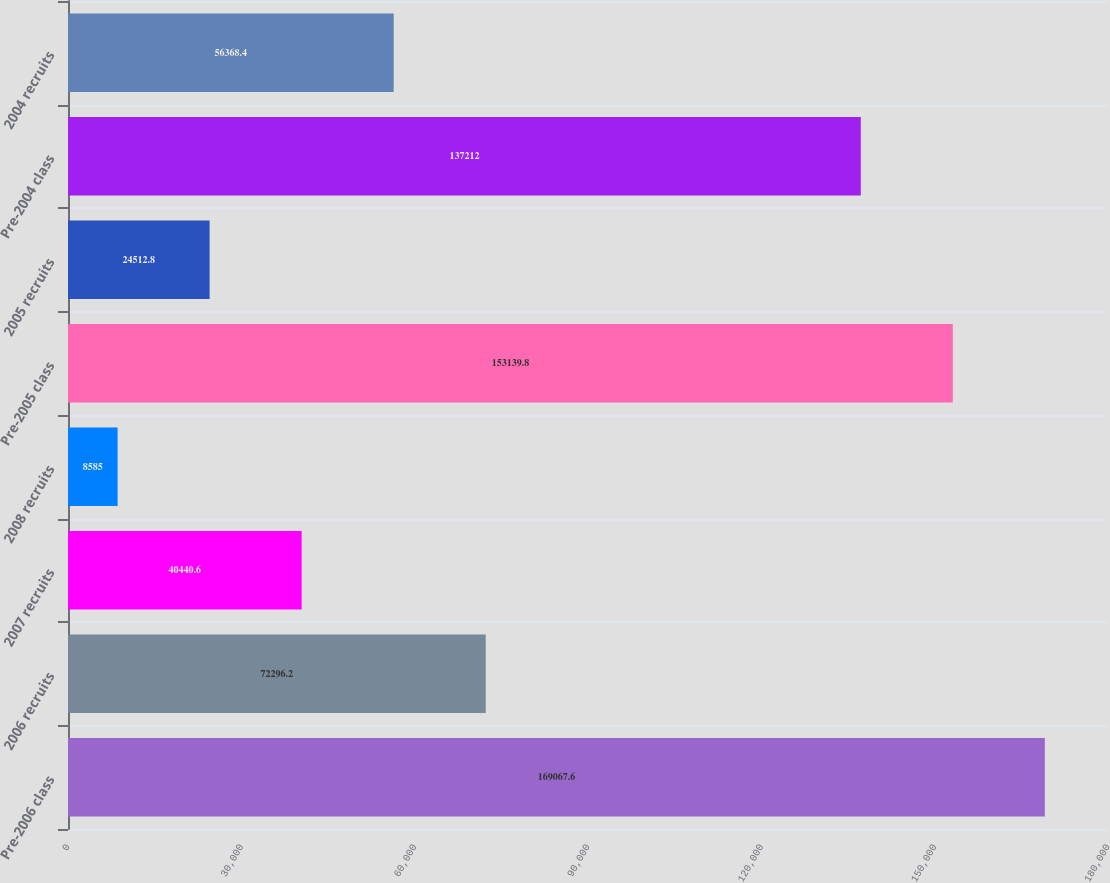Convert chart to OTSL. <chart><loc_0><loc_0><loc_500><loc_500><bar_chart><fcel>Pre-2006 class<fcel>2006 recruits<fcel>2007 recruits<fcel>2008 recruits<fcel>Pre-2005 class<fcel>2005 recruits<fcel>Pre-2004 class<fcel>2004 recruits<nl><fcel>169068<fcel>72296.2<fcel>40440.6<fcel>8585<fcel>153140<fcel>24512.8<fcel>137212<fcel>56368.4<nl></chart> 